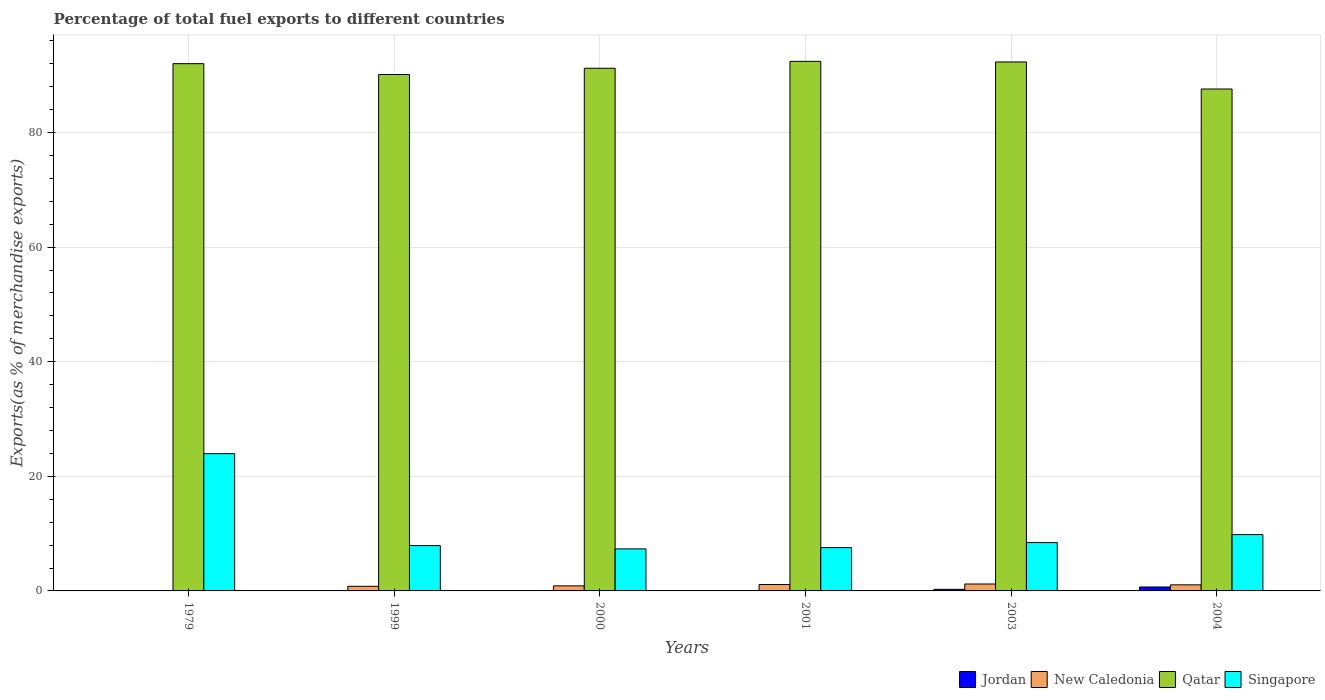How many different coloured bars are there?
Make the answer very short. 4. How many bars are there on the 5th tick from the left?
Your response must be concise. 4. How many bars are there on the 4th tick from the right?
Provide a short and direct response. 4. What is the label of the 6th group of bars from the left?
Keep it short and to the point. 2004. In how many cases, is the number of bars for a given year not equal to the number of legend labels?
Offer a very short reply. 0. What is the percentage of exports to different countries in New Caledonia in 1999?
Your answer should be compact. 0.8. Across all years, what is the maximum percentage of exports to different countries in Singapore?
Keep it short and to the point. 23.96. Across all years, what is the minimum percentage of exports to different countries in New Caledonia?
Offer a very short reply. 0.03. In which year was the percentage of exports to different countries in Singapore maximum?
Offer a terse response. 1979. In which year was the percentage of exports to different countries in Singapore minimum?
Make the answer very short. 2000. What is the total percentage of exports to different countries in Jordan in the graph?
Provide a short and direct response. 1.02. What is the difference between the percentage of exports to different countries in Qatar in 1999 and that in 2004?
Offer a very short reply. 2.53. What is the difference between the percentage of exports to different countries in Jordan in 1979 and the percentage of exports to different countries in New Caledonia in 2004?
Give a very brief answer. -1.05. What is the average percentage of exports to different countries in Singapore per year?
Offer a terse response. 10.84. In the year 2004, what is the difference between the percentage of exports to different countries in Jordan and percentage of exports to different countries in Singapore?
Offer a terse response. -9.14. What is the ratio of the percentage of exports to different countries in Jordan in 2000 to that in 2004?
Ensure brevity in your answer.  0.03. Is the percentage of exports to different countries in New Caledonia in 1979 less than that in 2001?
Ensure brevity in your answer.  Yes. What is the difference between the highest and the second highest percentage of exports to different countries in New Caledonia?
Provide a succinct answer. 0.09. What is the difference between the highest and the lowest percentage of exports to different countries in Jordan?
Make the answer very short. 0.68. In how many years, is the percentage of exports to different countries in Singapore greater than the average percentage of exports to different countries in Singapore taken over all years?
Offer a very short reply. 1. Is the sum of the percentage of exports to different countries in Jordan in 2000 and 2004 greater than the maximum percentage of exports to different countries in New Caledonia across all years?
Your response must be concise. No. What does the 2nd bar from the left in 2001 represents?
Your answer should be very brief. New Caledonia. What does the 2nd bar from the right in 1979 represents?
Ensure brevity in your answer.  Qatar. Are all the bars in the graph horizontal?
Offer a very short reply. No. How many years are there in the graph?
Give a very brief answer. 6. Where does the legend appear in the graph?
Ensure brevity in your answer.  Bottom right. How many legend labels are there?
Your answer should be very brief. 4. How are the legend labels stacked?
Give a very brief answer. Horizontal. What is the title of the graph?
Make the answer very short. Percentage of total fuel exports to different countries. Does "Tunisia" appear as one of the legend labels in the graph?
Your answer should be compact. No. What is the label or title of the X-axis?
Offer a terse response. Years. What is the label or title of the Y-axis?
Provide a short and direct response. Exports(as % of merchandise exports). What is the Exports(as % of merchandise exports) of Jordan in 1979?
Keep it short and to the point. 0.01. What is the Exports(as % of merchandise exports) in New Caledonia in 1979?
Offer a very short reply. 0.03. What is the Exports(as % of merchandise exports) of Qatar in 1979?
Give a very brief answer. 92.03. What is the Exports(as % of merchandise exports) in Singapore in 1979?
Your answer should be compact. 23.96. What is the Exports(as % of merchandise exports) of Jordan in 1999?
Your answer should be compact. 0.01. What is the Exports(as % of merchandise exports) of New Caledonia in 1999?
Provide a short and direct response. 0.8. What is the Exports(as % of merchandise exports) in Qatar in 1999?
Ensure brevity in your answer.  90.13. What is the Exports(as % of merchandise exports) of Singapore in 1999?
Your answer should be compact. 7.91. What is the Exports(as % of merchandise exports) of Jordan in 2000?
Give a very brief answer. 0.02. What is the Exports(as % of merchandise exports) of New Caledonia in 2000?
Offer a very short reply. 0.88. What is the Exports(as % of merchandise exports) in Qatar in 2000?
Offer a terse response. 91.23. What is the Exports(as % of merchandise exports) of Singapore in 2000?
Offer a terse response. 7.34. What is the Exports(as % of merchandise exports) in Jordan in 2001?
Offer a terse response. 0.01. What is the Exports(as % of merchandise exports) of New Caledonia in 2001?
Your answer should be compact. 1.12. What is the Exports(as % of merchandise exports) in Qatar in 2001?
Provide a succinct answer. 92.43. What is the Exports(as % of merchandise exports) of Singapore in 2001?
Ensure brevity in your answer.  7.56. What is the Exports(as % of merchandise exports) of Jordan in 2003?
Offer a very short reply. 0.28. What is the Exports(as % of merchandise exports) of New Caledonia in 2003?
Ensure brevity in your answer.  1.21. What is the Exports(as % of merchandise exports) in Qatar in 2003?
Keep it short and to the point. 92.32. What is the Exports(as % of merchandise exports) of Singapore in 2003?
Provide a succinct answer. 8.44. What is the Exports(as % of merchandise exports) of Jordan in 2004?
Provide a short and direct response. 0.69. What is the Exports(as % of merchandise exports) of New Caledonia in 2004?
Your response must be concise. 1.06. What is the Exports(as % of merchandise exports) in Qatar in 2004?
Offer a terse response. 87.6. What is the Exports(as % of merchandise exports) in Singapore in 2004?
Your answer should be very brief. 9.83. Across all years, what is the maximum Exports(as % of merchandise exports) of Jordan?
Your answer should be very brief. 0.69. Across all years, what is the maximum Exports(as % of merchandise exports) of New Caledonia?
Your answer should be very brief. 1.21. Across all years, what is the maximum Exports(as % of merchandise exports) in Qatar?
Provide a short and direct response. 92.43. Across all years, what is the maximum Exports(as % of merchandise exports) of Singapore?
Give a very brief answer. 23.96. Across all years, what is the minimum Exports(as % of merchandise exports) in Jordan?
Offer a terse response. 0.01. Across all years, what is the minimum Exports(as % of merchandise exports) in New Caledonia?
Offer a terse response. 0.03. Across all years, what is the minimum Exports(as % of merchandise exports) of Qatar?
Keep it short and to the point. 87.6. Across all years, what is the minimum Exports(as % of merchandise exports) in Singapore?
Make the answer very short. 7.34. What is the total Exports(as % of merchandise exports) in Jordan in the graph?
Your response must be concise. 1.02. What is the total Exports(as % of merchandise exports) in New Caledonia in the graph?
Offer a very short reply. 5.11. What is the total Exports(as % of merchandise exports) of Qatar in the graph?
Ensure brevity in your answer.  545.75. What is the total Exports(as % of merchandise exports) in Singapore in the graph?
Offer a terse response. 65.03. What is the difference between the Exports(as % of merchandise exports) in Jordan in 1979 and that in 1999?
Give a very brief answer. 0. What is the difference between the Exports(as % of merchandise exports) in New Caledonia in 1979 and that in 1999?
Provide a succinct answer. -0.77. What is the difference between the Exports(as % of merchandise exports) in Qatar in 1979 and that in 1999?
Give a very brief answer. 1.89. What is the difference between the Exports(as % of merchandise exports) in Singapore in 1979 and that in 1999?
Your response must be concise. 16.05. What is the difference between the Exports(as % of merchandise exports) in Jordan in 1979 and that in 2000?
Offer a terse response. -0.01. What is the difference between the Exports(as % of merchandise exports) in New Caledonia in 1979 and that in 2000?
Offer a very short reply. -0.85. What is the difference between the Exports(as % of merchandise exports) in Qatar in 1979 and that in 2000?
Your answer should be very brief. 0.8. What is the difference between the Exports(as % of merchandise exports) of Singapore in 1979 and that in 2000?
Give a very brief answer. 16.62. What is the difference between the Exports(as % of merchandise exports) in Jordan in 1979 and that in 2001?
Provide a succinct answer. 0. What is the difference between the Exports(as % of merchandise exports) in New Caledonia in 1979 and that in 2001?
Your answer should be compact. -1.09. What is the difference between the Exports(as % of merchandise exports) of Qatar in 1979 and that in 2001?
Give a very brief answer. -0.4. What is the difference between the Exports(as % of merchandise exports) in Singapore in 1979 and that in 2001?
Ensure brevity in your answer.  16.4. What is the difference between the Exports(as % of merchandise exports) of Jordan in 1979 and that in 2003?
Make the answer very short. -0.27. What is the difference between the Exports(as % of merchandise exports) of New Caledonia in 1979 and that in 2003?
Keep it short and to the point. -1.18. What is the difference between the Exports(as % of merchandise exports) of Qatar in 1979 and that in 2003?
Provide a succinct answer. -0.3. What is the difference between the Exports(as % of merchandise exports) of Singapore in 1979 and that in 2003?
Provide a succinct answer. 15.52. What is the difference between the Exports(as % of merchandise exports) in Jordan in 1979 and that in 2004?
Provide a short and direct response. -0.68. What is the difference between the Exports(as % of merchandise exports) of New Caledonia in 1979 and that in 2004?
Make the answer very short. -1.03. What is the difference between the Exports(as % of merchandise exports) in Qatar in 1979 and that in 2004?
Give a very brief answer. 4.43. What is the difference between the Exports(as % of merchandise exports) in Singapore in 1979 and that in 2004?
Offer a terse response. 14.13. What is the difference between the Exports(as % of merchandise exports) of Jordan in 1999 and that in 2000?
Make the answer very short. -0.01. What is the difference between the Exports(as % of merchandise exports) in New Caledonia in 1999 and that in 2000?
Your answer should be very brief. -0.08. What is the difference between the Exports(as % of merchandise exports) of Qatar in 1999 and that in 2000?
Your response must be concise. -1.09. What is the difference between the Exports(as % of merchandise exports) in Singapore in 1999 and that in 2000?
Offer a terse response. 0.57. What is the difference between the Exports(as % of merchandise exports) in New Caledonia in 1999 and that in 2001?
Your response must be concise. -0.32. What is the difference between the Exports(as % of merchandise exports) in Qatar in 1999 and that in 2001?
Your response must be concise. -2.3. What is the difference between the Exports(as % of merchandise exports) in Singapore in 1999 and that in 2001?
Your answer should be very brief. 0.35. What is the difference between the Exports(as % of merchandise exports) in Jordan in 1999 and that in 2003?
Provide a short and direct response. -0.27. What is the difference between the Exports(as % of merchandise exports) in New Caledonia in 1999 and that in 2003?
Provide a succinct answer. -0.41. What is the difference between the Exports(as % of merchandise exports) of Qatar in 1999 and that in 2003?
Keep it short and to the point. -2.19. What is the difference between the Exports(as % of merchandise exports) of Singapore in 1999 and that in 2003?
Give a very brief answer. -0.53. What is the difference between the Exports(as % of merchandise exports) in Jordan in 1999 and that in 2004?
Give a very brief answer. -0.68. What is the difference between the Exports(as % of merchandise exports) of New Caledonia in 1999 and that in 2004?
Your answer should be very brief. -0.26. What is the difference between the Exports(as % of merchandise exports) in Qatar in 1999 and that in 2004?
Provide a succinct answer. 2.53. What is the difference between the Exports(as % of merchandise exports) of Singapore in 1999 and that in 2004?
Provide a succinct answer. -1.92. What is the difference between the Exports(as % of merchandise exports) of Jordan in 2000 and that in 2001?
Ensure brevity in your answer.  0.01. What is the difference between the Exports(as % of merchandise exports) in New Caledonia in 2000 and that in 2001?
Offer a terse response. -0.24. What is the difference between the Exports(as % of merchandise exports) of Qatar in 2000 and that in 2001?
Offer a very short reply. -1.2. What is the difference between the Exports(as % of merchandise exports) of Singapore in 2000 and that in 2001?
Keep it short and to the point. -0.22. What is the difference between the Exports(as % of merchandise exports) of Jordan in 2000 and that in 2003?
Your answer should be very brief. -0.26. What is the difference between the Exports(as % of merchandise exports) of New Caledonia in 2000 and that in 2003?
Keep it short and to the point. -0.33. What is the difference between the Exports(as % of merchandise exports) of Qatar in 2000 and that in 2003?
Provide a succinct answer. -1.1. What is the difference between the Exports(as % of merchandise exports) in Singapore in 2000 and that in 2003?
Provide a short and direct response. -1.1. What is the difference between the Exports(as % of merchandise exports) in New Caledonia in 2000 and that in 2004?
Your response must be concise. -0.18. What is the difference between the Exports(as % of merchandise exports) of Qatar in 2000 and that in 2004?
Provide a succinct answer. 3.62. What is the difference between the Exports(as % of merchandise exports) of Singapore in 2000 and that in 2004?
Provide a short and direct response. -2.5. What is the difference between the Exports(as % of merchandise exports) in Jordan in 2001 and that in 2003?
Ensure brevity in your answer.  -0.27. What is the difference between the Exports(as % of merchandise exports) in New Caledonia in 2001 and that in 2003?
Provide a short and direct response. -0.09. What is the difference between the Exports(as % of merchandise exports) of Qatar in 2001 and that in 2003?
Make the answer very short. 0.11. What is the difference between the Exports(as % of merchandise exports) in Singapore in 2001 and that in 2003?
Provide a short and direct response. -0.88. What is the difference between the Exports(as % of merchandise exports) of Jordan in 2001 and that in 2004?
Your response must be concise. -0.68. What is the difference between the Exports(as % of merchandise exports) of New Caledonia in 2001 and that in 2004?
Keep it short and to the point. 0.06. What is the difference between the Exports(as % of merchandise exports) of Qatar in 2001 and that in 2004?
Your answer should be very brief. 4.83. What is the difference between the Exports(as % of merchandise exports) in Singapore in 2001 and that in 2004?
Provide a succinct answer. -2.27. What is the difference between the Exports(as % of merchandise exports) of Jordan in 2003 and that in 2004?
Ensure brevity in your answer.  -0.41. What is the difference between the Exports(as % of merchandise exports) of New Caledonia in 2003 and that in 2004?
Give a very brief answer. 0.15. What is the difference between the Exports(as % of merchandise exports) of Qatar in 2003 and that in 2004?
Provide a short and direct response. 4.72. What is the difference between the Exports(as % of merchandise exports) in Singapore in 2003 and that in 2004?
Keep it short and to the point. -1.4. What is the difference between the Exports(as % of merchandise exports) in Jordan in 1979 and the Exports(as % of merchandise exports) in New Caledonia in 1999?
Give a very brief answer. -0.79. What is the difference between the Exports(as % of merchandise exports) of Jordan in 1979 and the Exports(as % of merchandise exports) of Qatar in 1999?
Give a very brief answer. -90.12. What is the difference between the Exports(as % of merchandise exports) in Jordan in 1979 and the Exports(as % of merchandise exports) in Singapore in 1999?
Provide a short and direct response. -7.9. What is the difference between the Exports(as % of merchandise exports) of New Caledonia in 1979 and the Exports(as % of merchandise exports) of Qatar in 1999?
Provide a short and direct response. -90.1. What is the difference between the Exports(as % of merchandise exports) in New Caledonia in 1979 and the Exports(as % of merchandise exports) in Singapore in 1999?
Offer a terse response. -7.88. What is the difference between the Exports(as % of merchandise exports) of Qatar in 1979 and the Exports(as % of merchandise exports) of Singapore in 1999?
Provide a short and direct response. 84.12. What is the difference between the Exports(as % of merchandise exports) in Jordan in 1979 and the Exports(as % of merchandise exports) in New Caledonia in 2000?
Offer a terse response. -0.87. What is the difference between the Exports(as % of merchandise exports) of Jordan in 1979 and the Exports(as % of merchandise exports) of Qatar in 2000?
Offer a terse response. -91.21. What is the difference between the Exports(as % of merchandise exports) of Jordan in 1979 and the Exports(as % of merchandise exports) of Singapore in 2000?
Keep it short and to the point. -7.32. What is the difference between the Exports(as % of merchandise exports) of New Caledonia in 1979 and the Exports(as % of merchandise exports) of Qatar in 2000?
Ensure brevity in your answer.  -91.2. What is the difference between the Exports(as % of merchandise exports) of New Caledonia in 1979 and the Exports(as % of merchandise exports) of Singapore in 2000?
Ensure brevity in your answer.  -7.31. What is the difference between the Exports(as % of merchandise exports) of Qatar in 1979 and the Exports(as % of merchandise exports) of Singapore in 2000?
Make the answer very short. 84.69. What is the difference between the Exports(as % of merchandise exports) in Jordan in 1979 and the Exports(as % of merchandise exports) in New Caledonia in 2001?
Provide a short and direct response. -1.11. What is the difference between the Exports(as % of merchandise exports) of Jordan in 1979 and the Exports(as % of merchandise exports) of Qatar in 2001?
Give a very brief answer. -92.42. What is the difference between the Exports(as % of merchandise exports) of Jordan in 1979 and the Exports(as % of merchandise exports) of Singapore in 2001?
Your answer should be very brief. -7.55. What is the difference between the Exports(as % of merchandise exports) of New Caledonia in 1979 and the Exports(as % of merchandise exports) of Qatar in 2001?
Make the answer very short. -92.4. What is the difference between the Exports(as % of merchandise exports) in New Caledonia in 1979 and the Exports(as % of merchandise exports) in Singapore in 2001?
Offer a very short reply. -7.53. What is the difference between the Exports(as % of merchandise exports) in Qatar in 1979 and the Exports(as % of merchandise exports) in Singapore in 2001?
Provide a short and direct response. 84.47. What is the difference between the Exports(as % of merchandise exports) of Jordan in 1979 and the Exports(as % of merchandise exports) of New Caledonia in 2003?
Keep it short and to the point. -1.2. What is the difference between the Exports(as % of merchandise exports) in Jordan in 1979 and the Exports(as % of merchandise exports) in Qatar in 2003?
Ensure brevity in your answer.  -92.31. What is the difference between the Exports(as % of merchandise exports) of Jordan in 1979 and the Exports(as % of merchandise exports) of Singapore in 2003?
Offer a very short reply. -8.42. What is the difference between the Exports(as % of merchandise exports) in New Caledonia in 1979 and the Exports(as % of merchandise exports) in Qatar in 2003?
Offer a very short reply. -92.29. What is the difference between the Exports(as % of merchandise exports) in New Caledonia in 1979 and the Exports(as % of merchandise exports) in Singapore in 2003?
Your answer should be very brief. -8.41. What is the difference between the Exports(as % of merchandise exports) in Qatar in 1979 and the Exports(as % of merchandise exports) in Singapore in 2003?
Make the answer very short. 83.59. What is the difference between the Exports(as % of merchandise exports) of Jordan in 1979 and the Exports(as % of merchandise exports) of New Caledonia in 2004?
Make the answer very short. -1.05. What is the difference between the Exports(as % of merchandise exports) of Jordan in 1979 and the Exports(as % of merchandise exports) of Qatar in 2004?
Offer a terse response. -87.59. What is the difference between the Exports(as % of merchandise exports) of Jordan in 1979 and the Exports(as % of merchandise exports) of Singapore in 2004?
Ensure brevity in your answer.  -9.82. What is the difference between the Exports(as % of merchandise exports) in New Caledonia in 1979 and the Exports(as % of merchandise exports) in Qatar in 2004?
Your response must be concise. -87.57. What is the difference between the Exports(as % of merchandise exports) of New Caledonia in 1979 and the Exports(as % of merchandise exports) of Singapore in 2004?
Provide a succinct answer. -9.8. What is the difference between the Exports(as % of merchandise exports) in Qatar in 1979 and the Exports(as % of merchandise exports) in Singapore in 2004?
Keep it short and to the point. 82.2. What is the difference between the Exports(as % of merchandise exports) in Jordan in 1999 and the Exports(as % of merchandise exports) in New Caledonia in 2000?
Give a very brief answer. -0.87. What is the difference between the Exports(as % of merchandise exports) in Jordan in 1999 and the Exports(as % of merchandise exports) in Qatar in 2000?
Ensure brevity in your answer.  -91.22. What is the difference between the Exports(as % of merchandise exports) in Jordan in 1999 and the Exports(as % of merchandise exports) in Singapore in 2000?
Ensure brevity in your answer.  -7.33. What is the difference between the Exports(as % of merchandise exports) of New Caledonia in 1999 and the Exports(as % of merchandise exports) of Qatar in 2000?
Provide a short and direct response. -90.42. What is the difference between the Exports(as % of merchandise exports) of New Caledonia in 1999 and the Exports(as % of merchandise exports) of Singapore in 2000?
Provide a succinct answer. -6.53. What is the difference between the Exports(as % of merchandise exports) of Qatar in 1999 and the Exports(as % of merchandise exports) of Singapore in 2000?
Your answer should be very brief. 82.8. What is the difference between the Exports(as % of merchandise exports) in Jordan in 1999 and the Exports(as % of merchandise exports) in New Caledonia in 2001?
Give a very brief answer. -1.11. What is the difference between the Exports(as % of merchandise exports) in Jordan in 1999 and the Exports(as % of merchandise exports) in Qatar in 2001?
Provide a succinct answer. -92.42. What is the difference between the Exports(as % of merchandise exports) in Jordan in 1999 and the Exports(as % of merchandise exports) in Singapore in 2001?
Make the answer very short. -7.55. What is the difference between the Exports(as % of merchandise exports) of New Caledonia in 1999 and the Exports(as % of merchandise exports) of Qatar in 2001?
Offer a very short reply. -91.63. What is the difference between the Exports(as % of merchandise exports) in New Caledonia in 1999 and the Exports(as % of merchandise exports) in Singapore in 2001?
Offer a terse response. -6.76. What is the difference between the Exports(as % of merchandise exports) in Qatar in 1999 and the Exports(as % of merchandise exports) in Singapore in 2001?
Your response must be concise. 82.57. What is the difference between the Exports(as % of merchandise exports) in Jordan in 1999 and the Exports(as % of merchandise exports) in New Caledonia in 2003?
Offer a very short reply. -1.2. What is the difference between the Exports(as % of merchandise exports) in Jordan in 1999 and the Exports(as % of merchandise exports) in Qatar in 2003?
Your response must be concise. -92.31. What is the difference between the Exports(as % of merchandise exports) in Jordan in 1999 and the Exports(as % of merchandise exports) in Singapore in 2003?
Provide a short and direct response. -8.43. What is the difference between the Exports(as % of merchandise exports) in New Caledonia in 1999 and the Exports(as % of merchandise exports) in Qatar in 2003?
Give a very brief answer. -91.52. What is the difference between the Exports(as % of merchandise exports) of New Caledonia in 1999 and the Exports(as % of merchandise exports) of Singapore in 2003?
Your answer should be compact. -7.63. What is the difference between the Exports(as % of merchandise exports) of Qatar in 1999 and the Exports(as % of merchandise exports) of Singapore in 2003?
Provide a succinct answer. 81.7. What is the difference between the Exports(as % of merchandise exports) in Jordan in 1999 and the Exports(as % of merchandise exports) in New Caledonia in 2004?
Provide a succinct answer. -1.05. What is the difference between the Exports(as % of merchandise exports) of Jordan in 1999 and the Exports(as % of merchandise exports) of Qatar in 2004?
Provide a succinct answer. -87.59. What is the difference between the Exports(as % of merchandise exports) in Jordan in 1999 and the Exports(as % of merchandise exports) in Singapore in 2004?
Offer a very short reply. -9.82. What is the difference between the Exports(as % of merchandise exports) in New Caledonia in 1999 and the Exports(as % of merchandise exports) in Qatar in 2004?
Ensure brevity in your answer.  -86.8. What is the difference between the Exports(as % of merchandise exports) in New Caledonia in 1999 and the Exports(as % of merchandise exports) in Singapore in 2004?
Provide a succinct answer. -9.03. What is the difference between the Exports(as % of merchandise exports) in Qatar in 1999 and the Exports(as % of merchandise exports) in Singapore in 2004?
Offer a very short reply. 80.3. What is the difference between the Exports(as % of merchandise exports) in Jordan in 2000 and the Exports(as % of merchandise exports) in New Caledonia in 2001?
Your answer should be very brief. -1.1. What is the difference between the Exports(as % of merchandise exports) in Jordan in 2000 and the Exports(as % of merchandise exports) in Qatar in 2001?
Offer a very short reply. -92.41. What is the difference between the Exports(as % of merchandise exports) in Jordan in 2000 and the Exports(as % of merchandise exports) in Singapore in 2001?
Make the answer very short. -7.54. What is the difference between the Exports(as % of merchandise exports) in New Caledonia in 2000 and the Exports(as % of merchandise exports) in Qatar in 2001?
Your response must be concise. -91.55. What is the difference between the Exports(as % of merchandise exports) of New Caledonia in 2000 and the Exports(as % of merchandise exports) of Singapore in 2001?
Your answer should be compact. -6.68. What is the difference between the Exports(as % of merchandise exports) in Qatar in 2000 and the Exports(as % of merchandise exports) in Singapore in 2001?
Make the answer very short. 83.67. What is the difference between the Exports(as % of merchandise exports) of Jordan in 2000 and the Exports(as % of merchandise exports) of New Caledonia in 2003?
Offer a terse response. -1.19. What is the difference between the Exports(as % of merchandise exports) of Jordan in 2000 and the Exports(as % of merchandise exports) of Qatar in 2003?
Provide a succinct answer. -92.3. What is the difference between the Exports(as % of merchandise exports) of Jordan in 2000 and the Exports(as % of merchandise exports) of Singapore in 2003?
Your answer should be very brief. -8.42. What is the difference between the Exports(as % of merchandise exports) of New Caledonia in 2000 and the Exports(as % of merchandise exports) of Qatar in 2003?
Provide a short and direct response. -91.44. What is the difference between the Exports(as % of merchandise exports) in New Caledonia in 2000 and the Exports(as % of merchandise exports) in Singapore in 2003?
Offer a terse response. -7.55. What is the difference between the Exports(as % of merchandise exports) of Qatar in 2000 and the Exports(as % of merchandise exports) of Singapore in 2003?
Offer a terse response. 82.79. What is the difference between the Exports(as % of merchandise exports) in Jordan in 2000 and the Exports(as % of merchandise exports) in New Caledonia in 2004?
Your response must be concise. -1.04. What is the difference between the Exports(as % of merchandise exports) in Jordan in 2000 and the Exports(as % of merchandise exports) in Qatar in 2004?
Your answer should be compact. -87.58. What is the difference between the Exports(as % of merchandise exports) in Jordan in 2000 and the Exports(as % of merchandise exports) in Singapore in 2004?
Your response must be concise. -9.81. What is the difference between the Exports(as % of merchandise exports) in New Caledonia in 2000 and the Exports(as % of merchandise exports) in Qatar in 2004?
Your response must be concise. -86.72. What is the difference between the Exports(as % of merchandise exports) of New Caledonia in 2000 and the Exports(as % of merchandise exports) of Singapore in 2004?
Your answer should be very brief. -8.95. What is the difference between the Exports(as % of merchandise exports) of Qatar in 2000 and the Exports(as % of merchandise exports) of Singapore in 2004?
Provide a succinct answer. 81.39. What is the difference between the Exports(as % of merchandise exports) of Jordan in 2001 and the Exports(as % of merchandise exports) of New Caledonia in 2003?
Offer a very short reply. -1.2. What is the difference between the Exports(as % of merchandise exports) of Jordan in 2001 and the Exports(as % of merchandise exports) of Qatar in 2003?
Your answer should be very brief. -92.31. What is the difference between the Exports(as % of merchandise exports) of Jordan in 2001 and the Exports(as % of merchandise exports) of Singapore in 2003?
Provide a succinct answer. -8.43. What is the difference between the Exports(as % of merchandise exports) in New Caledonia in 2001 and the Exports(as % of merchandise exports) in Qatar in 2003?
Your response must be concise. -91.2. What is the difference between the Exports(as % of merchandise exports) of New Caledonia in 2001 and the Exports(as % of merchandise exports) of Singapore in 2003?
Offer a very short reply. -7.32. What is the difference between the Exports(as % of merchandise exports) of Qatar in 2001 and the Exports(as % of merchandise exports) of Singapore in 2003?
Keep it short and to the point. 83.99. What is the difference between the Exports(as % of merchandise exports) of Jordan in 2001 and the Exports(as % of merchandise exports) of New Caledonia in 2004?
Provide a succinct answer. -1.05. What is the difference between the Exports(as % of merchandise exports) in Jordan in 2001 and the Exports(as % of merchandise exports) in Qatar in 2004?
Provide a short and direct response. -87.59. What is the difference between the Exports(as % of merchandise exports) of Jordan in 2001 and the Exports(as % of merchandise exports) of Singapore in 2004?
Offer a very short reply. -9.82. What is the difference between the Exports(as % of merchandise exports) in New Caledonia in 2001 and the Exports(as % of merchandise exports) in Qatar in 2004?
Make the answer very short. -86.48. What is the difference between the Exports(as % of merchandise exports) of New Caledonia in 2001 and the Exports(as % of merchandise exports) of Singapore in 2004?
Provide a short and direct response. -8.71. What is the difference between the Exports(as % of merchandise exports) in Qatar in 2001 and the Exports(as % of merchandise exports) in Singapore in 2004?
Your answer should be very brief. 82.6. What is the difference between the Exports(as % of merchandise exports) in Jordan in 2003 and the Exports(as % of merchandise exports) in New Caledonia in 2004?
Your answer should be compact. -0.78. What is the difference between the Exports(as % of merchandise exports) in Jordan in 2003 and the Exports(as % of merchandise exports) in Qatar in 2004?
Provide a short and direct response. -87.33. What is the difference between the Exports(as % of merchandise exports) of Jordan in 2003 and the Exports(as % of merchandise exports) of Singapore in 2004?
Keep it short and to the point. -9.55. What is the difference between the Exports(as % of merchandise exports) in New Caledonia in 2003 and the Exports(as % of merchandise exports) in Qatar in 2004?
Make the answer very short. -86.39. What is the difference between the Exports(as % of merchandise exports) in New Caledonia in 2003 and the Exports(as % of merchandise exports) in Singapore in 2004?
Keep it short and to the point. -8.62. What is the difference between the Exports(as % of merchandise exports) of Qatar in 2003 and the Exports(as % of merchandise exports) of Singapore in 2004?
Your answer should be compact. 82.49. What is the average Exports(as % of merchandise exports) in Jordan per year?
Provide a succinct answer. 0.17. What is the average Exports(as % of merchandise exports) in New Caledonia per year?
Offer a terse response. 0.85. What is the average Exports(as % of merchandise exports) of Qatar per year?
Your answer should be very brief. 90.96. What is the average Exports(as % of merchandise exports) in Singapore per year?
Your response must be concise. 10.84. In the year 1979, what is the difference between the Exports(as % of merchandise exports) of Jordan and Exports(as % of merchandise exports) of New Caledonia?
Provide a succinct answer. -0.02. In the year 1979, what is the difference between the Exports(as % of merchandise exports) of Jordan and Exports(as % of merchandise exports) of Qatar?
Make the answer very short. -92.02. In the year 1979, what is the difference between the Exports(as % of merchandise exports) of Jordan and Exports(as % of merchandise exports) of Singapore?
Offer a very short reply. -23.94. In the year 1979, what is the difference between the Exports(as % of merchandise exports) in New Caledonia and Exports(as % of merchandise exports) in Qatar?
Offer a very short reply. -92. In the year 1979, what is the difference between the Exports(as % of merchandise exports) of New Caledonia and Exports(as % of merchandise exports) of Singapore?
Provide a succinct answer. -23.93. In the year 1979, what is the difference between the Exports(as % of merchandise exports) of Qatar and Exports(as % of merchandise exports) of Singapore?
Your answer should be very brief. 68.07. In the year 1999, what is the difference between the Exports(as % of merchandise exports) in Jordan and Exports(as % of merchandise exports) in New Caledonia?
Your answer should be compact. -0.79. In the year 1999, what is the difference between the Exports(as % of merchandise exports) in Jordan and Exports(as % of merchandise exports) in Qatar?
Ensure brevity in your answer.  -90.12. In the year 1999, what is the difference between the Exports(as % of merchandise exports) of Jordan and Exports(as % of merchandise exports) of Singapore?
Your answer should be compact. -7.9. In the year 1999, what is the difference between the Exports(as % of merchandise exports) in New Caledonia and Exports(as % of merchandise exports) in Qatar?
Offer a terse response. -89.33. In the year 1999, what is the difference between the Exports(as % of merchandise exports) of New Caledonia and Exports(as % of merchandise exports) of Singapore?
Keep it short and to the point. -7.11. In the year 1999, what is the difference between the Exports(as % of merchandise exports) in Qatar and Exports(as % of merchandise exports) in Singapore?
Your response must be concise. 82.22. In the year 2000, what is the difference between the Exports(as % of merchandise exports) in Jordan and Exports(as % of merchandise exports) in New Caledonia?
Your answer should be very brief. -0.86. In the year 2000, what is the difference between the Exports(as % of merchandise exports) in Jordan and Exports(as % of merchandise exports) in Qatar?
Offer a very short reply. -91.21. In the year 2000, what is the difference between the Exports(as % of merchandise exports) of Jordan and Exports(as % of merchandise exports) of Singapore?
Your answer should be compact. -7.32. In the year 2000, what is the difference between the Exports(as % of merchandise exports) of New Caledonia and Exports(as % of merchandise exports) of Qatar?
Your answer should be very brief. -90.34. In the year 2000, what is the difference between the Exports(as % of merchandise exports) in New Caledonia and Exports(as % of merchandise exports) in Singapore?
Offer a very short reply. -6.45. In the year 2000, what is the difference between the Exports(as % of merchandise exports) of Qatar and Exports(as % of merchandise exports) of Singapore?
Your response must be concise. 83.89. In the year 2001, what is the difference between the Exports(as % of merchandise exports) in Jordan and Exports(as % of merchandise exports) in New Caledonia?
Your answer should be very brief. -1.11. In the year 2001, what is the difference between the Exports(as % of merchandise exports) in Jordan and Exports(as % of merchandise exports) in Qatar?
Your answer should be very brief. -92.42. In the year 2001, what is the difference between the Exports(as % of merchandise exports) in Jordan and Exports(as % of merchandise exports) in Singapore?
Your answer should be very brief. -7.55. In the year 2001, what is the difference between the Exports(as % of merchandise exports) in New Caledonia and Exports(as % of merchandise exports) in Qatar?
Give a very brief answer. -91.31. In the year 2001, what is the difference between the Exports(as % of merchandise exports) in New Caledonia and Exports(as % of merchandise exports) in Singapore?
Give a very brief answer. -6.44. In the year 2001, what is the difference between the Exports(as % of merchandise exports) in Qatar and Exports(as % of merchandise exports) in Singapore?
Ensure brevity in your answer.  84.87. In the year 2003, what is the difference between the Exports(as % of merchandise exports) in Jordan and Exports(as % of merchandise exports) in New Caledonia?
Your answer should be compact. -0.93. In the year 2003, what is the difference between the Exports(as % of merchandise exports) in Jordan and Exports(as % of merchandise exports) in Qatar?
Give a very brief answer. -92.05. In the year 2003, what is the difference between the Exports(as % of merchandise exports) in Jordan and Exports(as % of merchandise exports) in Singapore?
Ensure brevity in your answer.  -8.16. In the year 2003, what is the difference between the Exports(as % of merchandise exports) of New Caledonia and Exports(as % of merchandise exports) of Qatar?
Offer a very short reply. -91.11. In the year 2003, what is the difference between the Exports(as % of merchandise exports) in New Caledonia and Exports(as % of merchandise exports) in Singapore?
Provide a short and direct response. -7.23. In the year 2003, what is the difference between the Exports(as % of merchandise exports) in Qatar and Exports(as % of merchandise exports) in Singapore?
Offer a terse response. 83.89. In the year 2004, what is the difference between the Exports(as % of merchandise exports) in Jordan and Exports(as % of merchandise exports) in New Caledonia?
Provide a short and direct response. -0.37. In the year 2004, what is the difference between the Exports(as % of merchandise exports) of Jordan and Exports(as % of merchandise exports) of Qatar?
Give a very brief answer. -86.92. In the year 2004, what is the difference between the Exports(as % of merchandise exports) of Jordan and Exports(as % of merchandise exports) of Singapore?
Your answer should be compact. -9.14. In the year 2004, what is the difference between the Exports(as % of merchandise exports) of New Caledonia and Exports(as % of merchandise exports) of Qatar?
Offer a very short reply. -86.54. In the year 2004, what is the difference between the Exports(as % of merchandise exports) in New Caledonia and Exports(as % of merchandise exports) in Singapore?
Give a very brief answer. -8.77. In the year 2004, what is the difference between the Exports(as % of merchandise exports) in Qatar and Exports(as % of merchandise exports) in Singapore?
Provide a succinct answer. 77.77. What is the ratio of the Exports(as % of merchandise exports) in Jordan in 1979 to that in 1999?
Provide a short and direct response. 1.12. What is the ratio of the Exports(as % of merchandise exports) of New Caledonia in 1979 to that in 1999?
Make the answer very short. 0.04. What is the ratio of the Exports(as % of merchandise exports) of Singapore in 1979 to that in 1999?
Offer a terse response. 3.03. What is the ratio of the Exports(as % of merchandise exports) in Jordan in 1979 to that in 2000?
Make the answer very short. 0.61. What is the ratio of the Exports(as % of merchandise exports) in New Caledonia in 1979 to that in 2000?
Give a very brief answer. 0.03. What is the ratio of the Exports(as % of merchandise exports) of Qatar in 1979 to that in 2000?
Ensure brevity in your answer.  1.01. What is the ratio of the Exports(as % of merchandise exports) in Singapore in 1979 to that in 2000?
Your response must be concise. 3.27. What is the ratio of the Exports(as % of merchandise exports) of Jordan in 1979 to that in 2001?
Your response must be concise. 1.16. What is the ratio of the Exports(as % of merchandise exports) of New Caledonia in 1979 to that in 2001?
Your answer should be very brief. 0.03. What is the ratio of the Exports(as % of merchandise exports) in Qatar in 1979 to that in 2001?
Ensure brevity in your answer.  1. What is the ratio of the Exports(as % of merchandise exports) in Singapore in 1979 to that in 2001?
Your answer should be compact. 3.17. What is the ratio of the Exports(as % of merchandise exports) in Jordan in 1979 to that in 2003?
Offer a terse response. 0.05. What is the ratio of the Exports(as % of merchandise exports) of New Caledonia in 1979 to that in 2003?
Your answer should be very brief. 0.02. What is the ratio of the Exports(as % of merchandise exports) of Singapore in 1979 to that in 2003?
Ensure brevity in your answer.  2.84. What is the ratio of the Exports(as % of merchandise exports) of Jordan in 1979 to that in 2004?
Ensure brevity in your answer.  0.02. What is the ratio of the Exports(as % of merchandise exports) in New Caledonia in 1979 to that in 2004?
Ensure brevity in your answer.  0.03. What is the ratio of the Exports(as % of merchandise exports) of Qatar in 1979 to that in 2004?
Ensure brevity in your answer.  1.05. What is the ratio of the Exports(as % of merchandise exports) in Singapore in 1979 to that in 2004?
Provide a succinct answer. 2.44. What is the ratio of the Exports(as % of merchandise exports) in Jordan in 1999 to that in 2000?
Provide a succinct answer. 0.54. What is the ratio of the Exports(as % of merchandise exports) of New Caledonia in 1999 to that in 2000?
Your answer should be very brief. 0.91. What is the ratio of the Exports(as % of merchandise exports) in Singapore in 1999 to that in 2000?
Ensure brevity in your answer.  1.08. What is the ratio of the Exports(as % of merchandise exports) of Jordan in 1999 to that in 2001?
Provide a succinct answer. 1.04. What is the ratio of the Exports(as % of merchandise exports) of New Caledonia in 1999 to that in 2001?
Your answer should be compact. 0.72. What is the ratio of the Exports(as % of merchandise exports) in Qatar in 1999 to that in 2001?
Make the answer very short. 0.98. What is the ratio of the Exports(as % of merchandise exports) of Singapore in 1999 to that in 2001?
Your answer should be very brief. 1.05. What is the ratio of the Exports(as % of merchandise exports) of Jordan in 1999 to that in 2003?
Provide a succinct answer. 0.04. What is the ratio of the Exports(as % of merchandise exports) of New Caledonia in 1999 to that in 2003?
Offer a very short reply. 0.66. What is the ratio of the Exports(as % of merchandise exports) in Qatar in 1999 to that in 2003?
Ensure brevity in your answer.  0.98. What is the ratio of the Exports(as % of merchandise exports) in Singapore in 1999 to that in 2003?
Provide a succinct answer. 0.94. What is the ratio of the Exports(as % of merchandise exports) of Jordan in 1999 to that in 2004?
Make the answer very short. 0.02. What is the ratio of the Exports(as % of merchandise exports) in New Caledonia in 1999 to that in 2004?
Give a very brief answer. 0.75. What is the ratio of the Exports(as % of merchandise exports) in Qatar in 1999 to that in 2004?
Offer a very short reply. 1.03. What is the ratio of the Exports(as % of merchandise exports) of Singapore in 1999 to that in 2004?
Offer a terse response. 0.8. What is the ratio of the Exports(as % of merchandise exports) of Jordan in 2000 to that in 2001?
Provide a succinct answer. 1.92. What is the ratio of the Exports(as % of merchandise exports) in New Caledonia in 2000 to that in 2001?
Provide a short and direct response. 0.79. What is the ratio of the Exports(as % of merchandise exports) of Qatar in 2000 to that in 2001?
Give a very brief answer. 0.99. What is the ratio of the Exports(as % of merchandise exports) of Singapore in 2000 to that in 2001?
Provide a succinct answer. 0.97. What is the ratio of the Exports(as % of merchandise exports) in Jordan in 2000 to that in 2003?
Offer a very short reply. 0.08. What is the ratio of the Exports(as % of merchandise exports) in New Caledonia in 2000 to that in 2003?
Ensure brevity in your answer.  0.73. What is the ratio of the Exports(as % of merchandise exports) in Singapore in 2000 to that in 2003?
Provide a succinct answer. 0.87. What is the ratio of the Exports(as % of merchandise exports) in Jordan in 2000 to that in 2004?
Provide a succinct answer. 0.03. What is the ratio of the Exports(as % of merchandise exports) of New Caledonia in 2000 to that in 2004?
Ensure brevity in your answer.  0.83. What is the ratio of the Exports(as % of merchandise exports) of Qatar in 2000 to that in 2004?
Provide a short and direct response. 1.04. What is the ratio of the Exports(as % of merchandise exports) of Singapore in 2000 to that in 2004?
Your answer should be compact. 0.75. What is the ratio of the Exports(as % of merchandise exports) of Jordan in 2001 to that in 2003?
Your answer should be very brief. 0.04. What is the ratio of the Exports(as % of merchandise exports) of New Caledonia in 2001 to that in 2003?
Ensure brevity in your answer.  0.93. What is the ratio of the Exports(as % of merchandise exports) of Qatar in 2001 to that in 2003?
Ensure brevity in your answer.  1. What is the ratio of the Exports(as % of merchandise exports) in Singapore in 2001 to that in 2003?
Keep it short and to the point. 0.9. What is the ratio of the Exports(as % of merchandise exports) in Jordan in 2001 to that in 2004?
Your answer should be very brief. 0.02. What is the ratio of the Exports(as % of merchandise exports) in New Caledonia in 2001 to that in 2004?
Your response must be concise. 1.05. What is the ratio of the Exports(as % of merchandise exports) of Qatar in 2001 to that in 2004?
Offer a terse response. 1.06. What is the ratio of the Exports(as % of merchandise exports) of Singapore in 2001 to that in 2004?
Your response must be concise. 0.77. What is the ratio of the Exports(as % of merchandise exports) in Jordan in 2003 to that in 2004?
Ensure brevity in your answer.  0.4. What is the ratio of the Exports(as % of merchandise exports) of New Caledonia in 2003 to that in 2004?
Provide a short and direct response. 1.14. What is the ratio of the Exports(as % of merchandise exports) in Qatar in 2003 to that in 2004?
Your answer should be very brief. 1.05. What is the ratio of the Exports(as % of merchandise exports) of Singapore in 2003 to that in 2004?
Provide a short and direct response. 0.86. What is the difference between the highest and the second highest Exports(as % of merchandise exports) in Jordan?
Ensure brevity in your answer.  0.41. What is the difference between the highest and the second highest Exports(as % of merchandise exports) of New Caledonia?
Make the answer very short. 0.09. What is the difference between the highest and the second highest Exports(as % of merchandise exports) in Qatar?
Your response must be concise. 0.11. What is the difference between the highest and the second highest Exports(as % of merchandise exports) of Singapore?
Provide a succinct answer. 14.13. What is the difference between the highest and the lowest Exports(as % of merchandise exports) in Jordan?
Ensure brevity in your answer.  0.68. What is the difference between the highest and the lowest Exports(as % of merchandise exports) in New Caledonia?
Your answer should be compact. 1.18. What is the difference between the highest and the lowest Exports(as % of merchandise exports) of Qatar?
Provide a short and direct response. 4.83. What is the difference between the highest and the lowest Exports(as % of merchandise exports) of Singapore?
Provide a succinct answer. 16.62. 